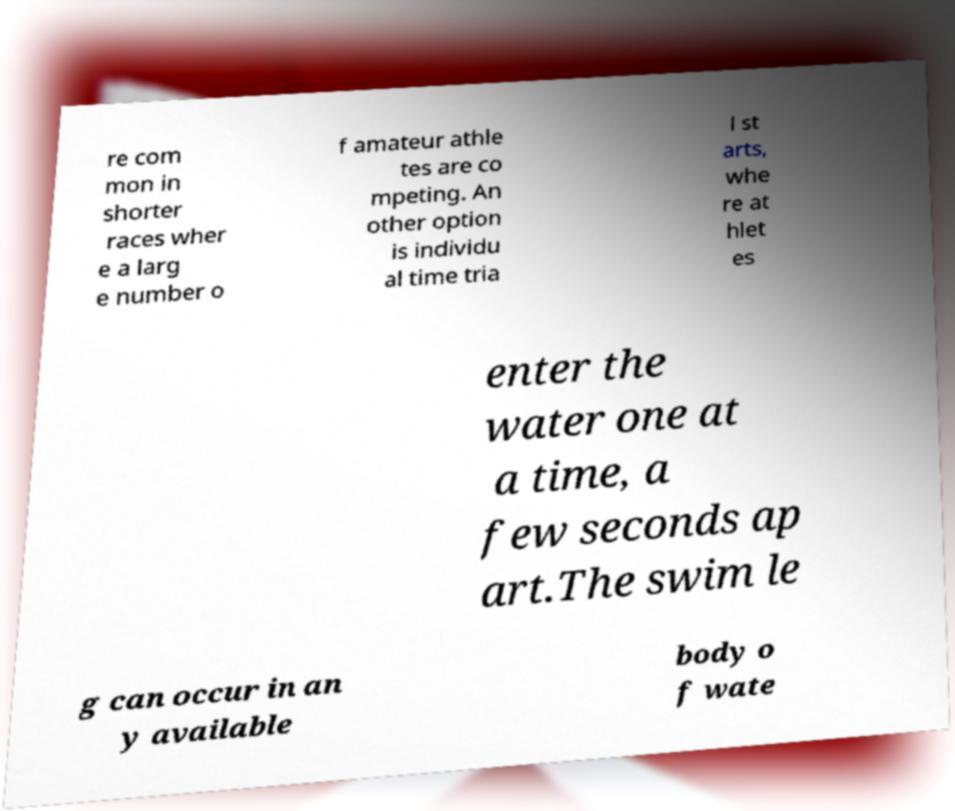Please identify and transcribe the text found in this image. re com mon in shorter races wher e a larg e number o f amateur athle tes are co mpeting. An other option is individu al time tria l st arts, whe re at hlet es enter the water one at a time, a few seconds ap art.The swim le g can occur in an y available body o f wate 